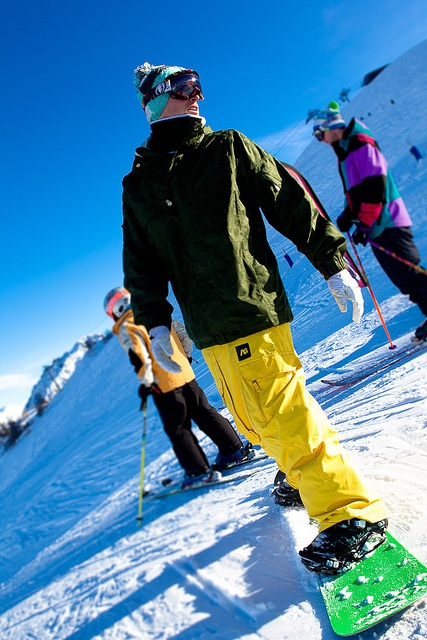Describe the objects in this image and their specific colors. I can see people in blue, black, gold, olive, and ivory tones, people in blue, black, purple, and navy tones, people in blue, black, olive, khaki, and gray tones, snowboard in blue, lightgreen, ivory, and lime tones, and skis in blue, white, and gray tones in this image. 